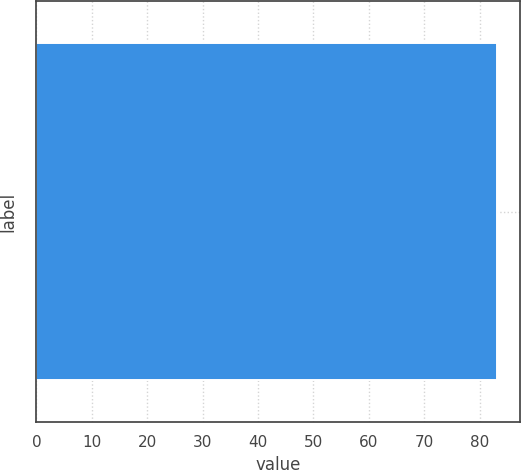Convert chart. <chart><loc_0><loc_0><loc_500><loc_500><bar_chart><ecel><nl><fcel>83.1<nl></chart> 